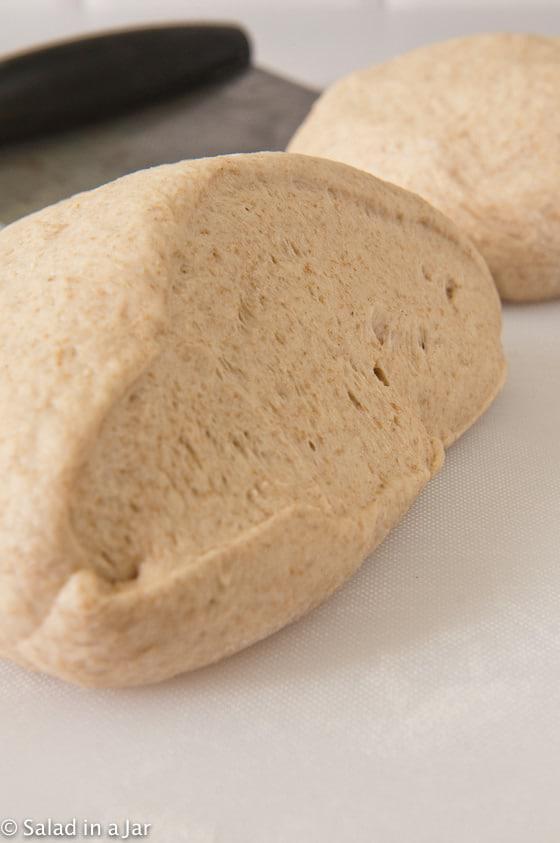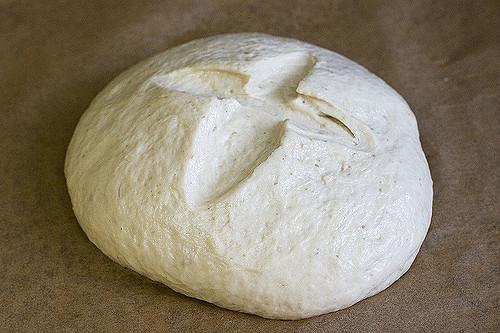The first image is the image on the left, the second image is the image on the right. Given the left and right images, does the statement "At least one image has a large ball of dough in a bowl-like container, and not directly on a flat surface." hold true? Answer yes or no. No. The first image is the image on the left, the second image is the image on the right. Evaluate the accuracy of this statement regarding the images: "Each image contains one rounded mound of bread dough, and at least one of the depicted dough mounds is in a metal container.". Is it true? Answer yes or no. No. 